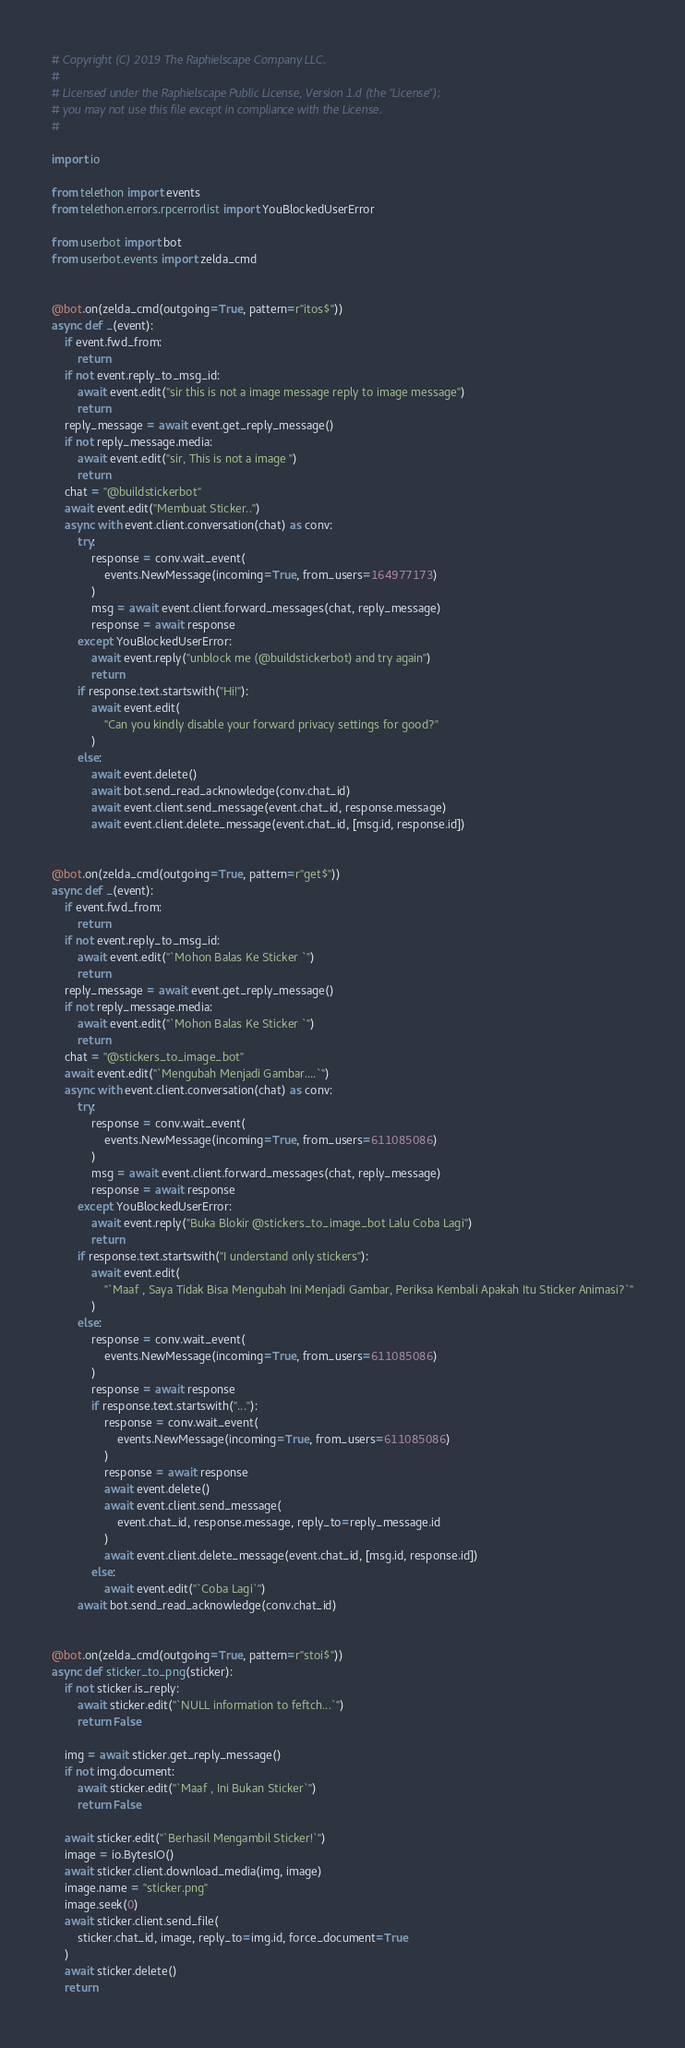<code> <loc_0><loc_0><loc_500><loc_500><_Python_># Copyright (C) 2019 The Raphielscape Company LLC.
#
# Licensed under the Raphielscape Public License, Version 1.d (the "License");
# you may not use this file except in compliance with the License.
#

import io

from telethon import events
from telethon.errors.rpcerrorlist import YouBlockedUserError

from userbot import bot
from userbot.events import zelda_cmd


@bot.on(zelda_cmd(outgoing=True, pattern=r"itos$"))
async def _(event):
    if event.fwd_from:
        return
    if not event.reply_to_msg_id:
        await event.edit("sir this is not a image message reply to image message")
        return
    reply_message = await event.get_reply_message()
    if not reply_message.media:
        await event.edit("sir, This is not a image ")
        return
    chat = "@buildstickerbot"
    await event.edit("Membuat Sticker..")
    async with event.client.conversation(chat) as conv:
        try:
            response = conv.wait_event(
                events.NewMessage(incoming=True, from_users=164977173)
            )
            msg = await event.client.forward_messages(chat, reply_message)
            response = await response
        except YouBlockedUserError:
            await event.reply("unblock me (@buildstickerbot) and try again")
            return
        if response.text.startswith("Hi!"):
            await event.edit(
                "Can you kindly disable your forward privacy settings for good?"
            )
        else:
            await event.delete()
            await bot.send_read_acknowledge(conv.chat_id)
            await event.client.send_message(event.chat_id, response.message)
            await event.client.delete_message(event.chat_id, [msg.id, response.id])


@bot.on(zelda_cmd(outgoing=True, pattern=r"get$"))
async def _(event):
    if event.fwd_from:
        return
    if not event.reply_to_msg_id:
        await event.edit("`Mohon Balas Ke Sticker `")
        return
    reply_message = await event.get_reply_message()
    if not reply_message.media:
        await event.edit("`Mohon Balas Ke Sticker `")
        return
    chat = "@stickers_to_image_bot"
    await event.edit("`Mengubah Menjadi Gambar....`")
    async with event.client.conversation(chat) as conv:
        try:
            response = conv.wait_event(
                events.NewMessage(incoming=True, from_users=611085086)
            )
            msg = await event.client.forward_messages(chat, reply_message)
            response = await response
        except YouBlockedUserError:
            await event.reply("Buka Blokir @stickers_to_image_bot Lalu Coba Lagi")
            return
        if response.text.startswith("I understand only stickers"):
            await event.edit(
                "`Maaf , Saya Tidak Bisa Mengubah Ini Menjadi Gambar, Periksa Kembali Apakah Itu Sticker Animasi?`"
            )
        else:
            response = conv.wait_event(
                events.NewMessage(incoming=True, from_users=611085086)
            )
            response = await response
            if response.text.startswith("..."):
                response = conv.wait_event(
                    events.NewMessage(incoming=True, from_users=611085086)
                )
                response = await response
                await event.delete()
                await event.client.send_message(
                    event.chat_id, response.message, reply_to=reply_message.id
                )
                await event.client.delete_message(event.chat_id, [msg.id, response.id])
            else:
                await event.edit("`Coba Lagi`")
        await bot.send_read_acknowledge(conv.chat_id)


@bot.on(zelda_cmd(outgoing=True, pattern=r"stoi$"))
async def sticker_to_png(sticker):
    if not sticker.is_reply:
        await sticker.edit("`NULL information to feftch...`")
        return False

    img = await sticker.get_reply_message()
    if not img.document:
        await sticker.edit("`Maaf , Ini Bukan Sticker`")
        return False

    await sticker.edit("`Berhasil Mengambil Sticker!`")
    image = io.BytesIO()
    await sticker.client.download_media(img, image)
    image.name = "sticker.png"
    image.seek(0)
    await sticker.client.send_file(
        sticker.chat_id, image, reply_to=img.id, force_document=True
    )
    await sticker.delete()
    return
</code> 